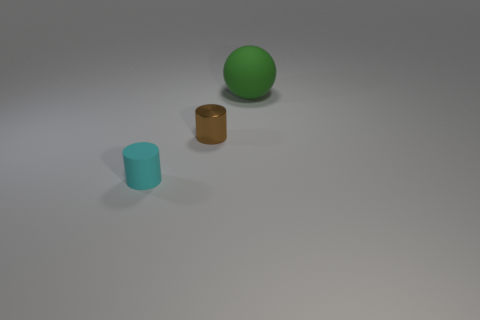Is the number of tiny cyan cylinders that are in front of the small cyan thing less than the number of tiny blue matte things?
Provide a short and direct response. No. How many cylinders are there?
Ensure brevity in your answer.  2. There is a small object to the right of the rubber object in front of the big green matte sphere; what shape is it?
Offer a terse response. Cylinder. What number of objects are behind the cyan matte cylinder?
Your answer should be compact. 2. Do the green thing and the small object right of the tiny cyan thing have the same material?
Offer a very short reply. No. Is there a matte thing that has the same size as the green sphere?
Offer a very short reply. No. Are there an equal number of small shiny cylinders on the right side of the rubber ball and rubber cubes?
Keep it short and to the point. Yes. What size is the shiny thing?
Keep it short and to the point. Small. How many small brown metallic objects are to the left of the rubber object to the left of the shiny thing?
Ensure brevity in your answer.  0. What number of small matte objects are the same color as the large matte object?
Offer a very short reply. 0. 